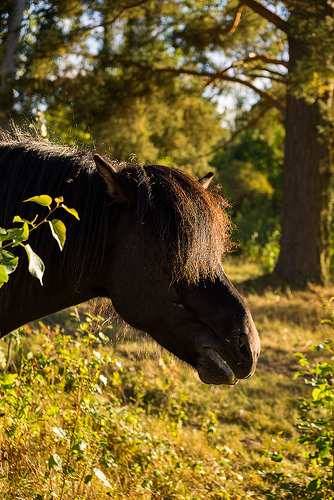<image>
Is there a horse under the tree? No. The horse is not positioned under the tree. The vertical relationship between these objects is different. 